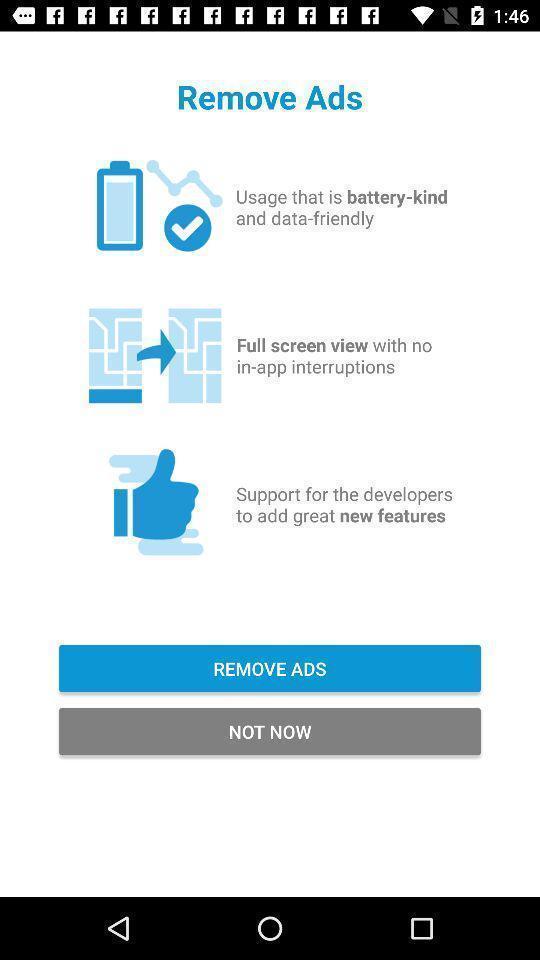Provide a textual representation of this image. Page displaying the support options to remove ads. 